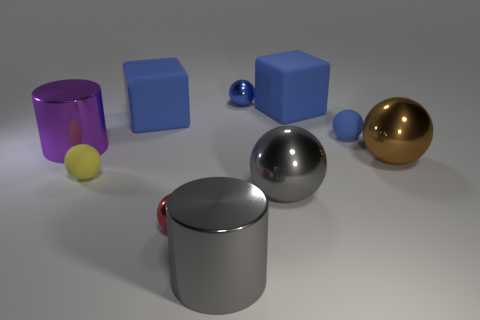There is a tiny blue shiny thing; what shape is it? sphere 